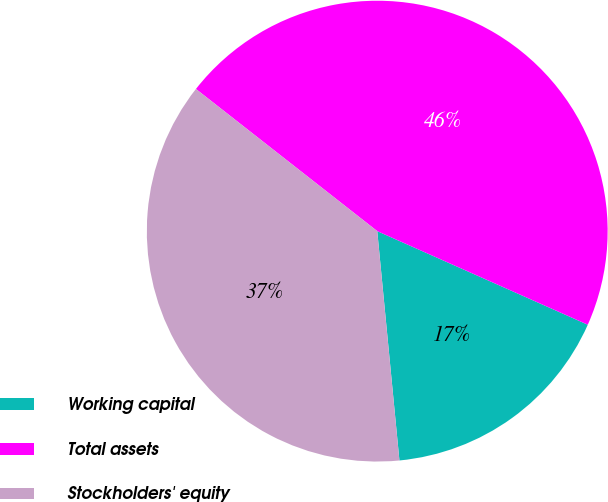Convert chart. <chart><loc_0><loc_0><loc_500><loc_500><pie_chart><fcel>Working capital<fcel>Total assets<fcel>Stockholders' equity<nl><fcel>16.81%<fcel>46.08%<fcel>37.12%<nl></chart> 